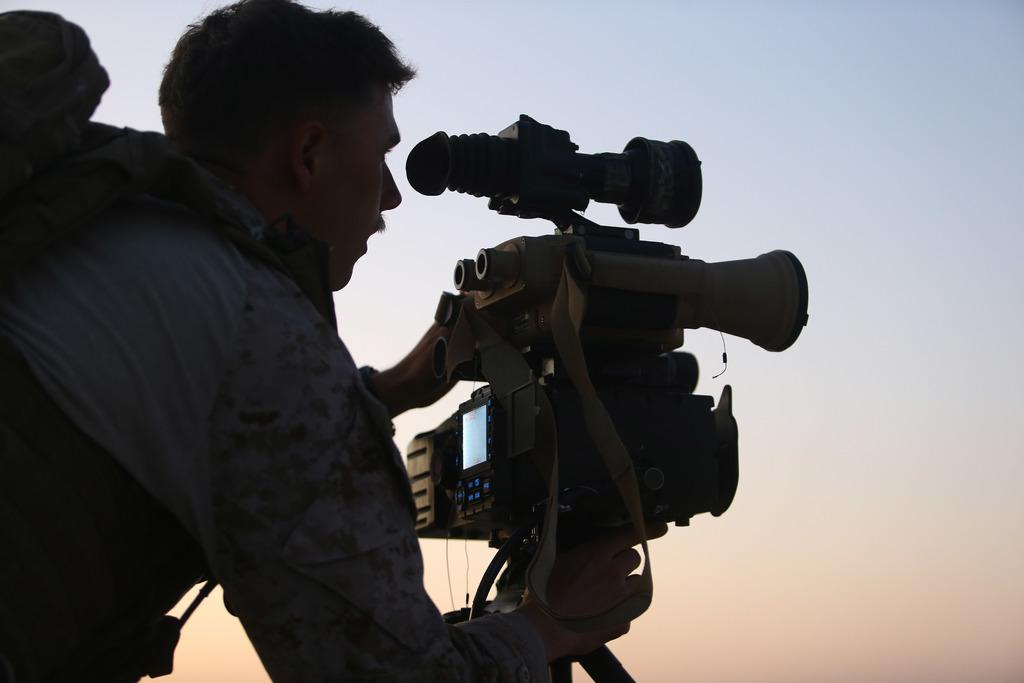What is the main subject of the image? The main subject of the image is a man. What is the man holding in the image? The man is holding a camera in the image. Where is the camera positioned in relation to the man? The camera is in front of the man. What type of box is the man using to measure the distance between the camera and himself? There is no box present in the image, and the man is not measuring any distances. 